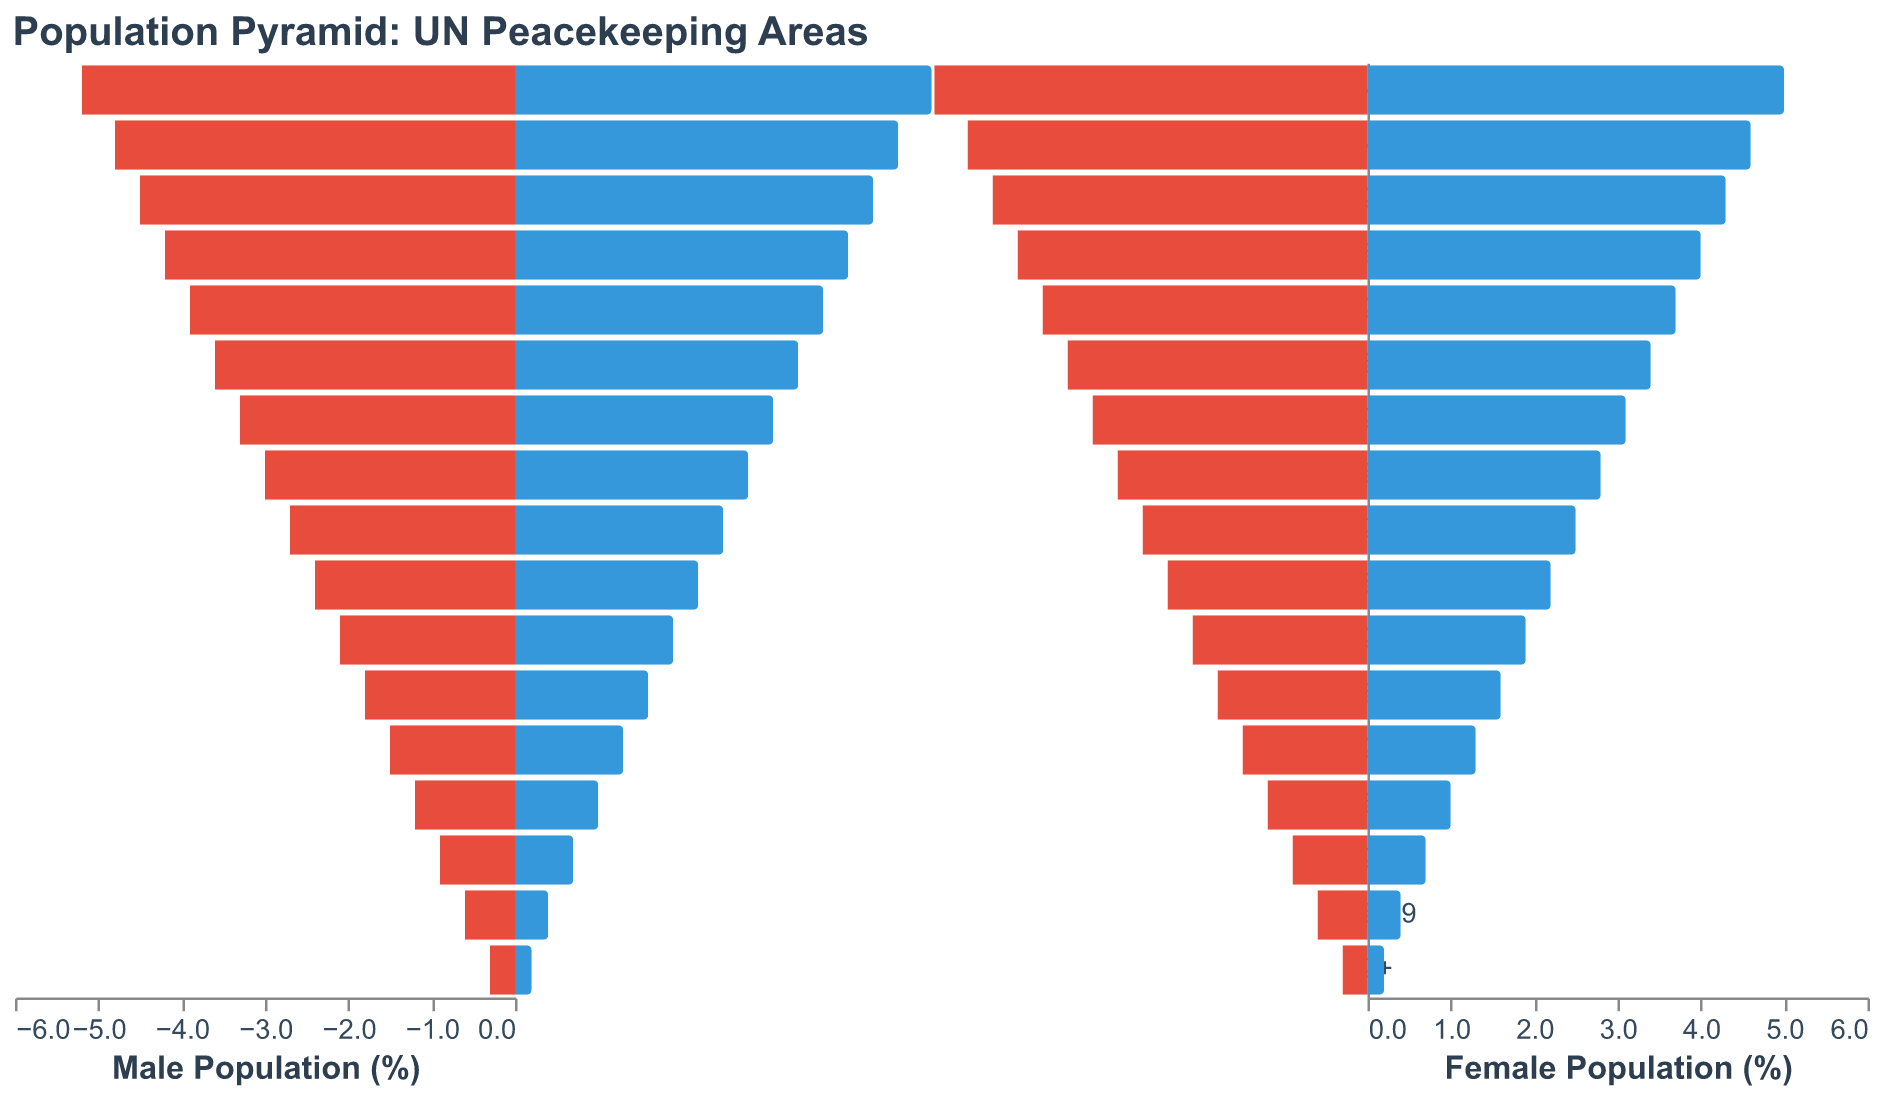What is the title of the plot? The title is clearly displayed at the top of the plot, reading "Population Pyramid: UN Peacekeeping Areas."
Answer: Population Pyramid: UN Peacekeeping Areas What is the percentage of the male population in the age group 0-4? The plot shows the male population for each age group on the left side. For the age group 0-4, the male population is indicated as 5.2%.
Answer: 5.2% Which age group has the smallest female population percentage? By examining the bars representing the female population on the right side of the plot, the age group 80+ has the smallest percentage, which is 0.2%.
Answer: 80+ What is the difference in the percentage of the male and female populations for the age group 25-29? For the age group 25-29, the percentage of the male population is 3.6%, and the female population is 3.4%. The difference is calculated as 3.6% - 3.4% = 0.2%.
Answer: 0.2% What is the combined percentage of the male and female populations for the age group 50-54? For the age group 50-54, the male population is 2.1% and the female population is 1.9%. Adding these together, 2.1% + 1.9% = 4.0%.
Answer: 4.0% How does the male population percentage change from the age group 0-4 to the age group 10-14? The male population percentage for the age group 0-4 is 5.2%, and for the age group 10-14, it is 4.5%. The change is 5.2% - 4.5% = 0.7%.
Answer: Decreases by 0.7% Which age group has a larger percentage of the population, males aged 15-19 or females aged 15-19? By looking at the plot, the male population percentage for 15-19 is 4.2%, and the female population percentage for the same age group is 4.0%. 4.2% is greater than 4.0%, indicating that males have a larger population percentage.
Answer: Males aged 15-19 What is the average percentage of the female population for the age groups 60-64 and 65-69? The female population percentage for the age group 60-64 is 1.3% and for the age group 65-69, it is 1.0%. The average is calculated as (1.3% + 1.0%) / 2 = 1.15%.
Answer: 1.15% Which gender has a higher population percentage in the age group 35-39? The figure shows that in the age group 35-39, males have a population percentage of 3.0%, whereas females have 2.8%. Thus, males have a higher population percentage in this age group.
Answer: Males How does the population percentage of females change from the age group 70-74 to 75-79? From the plot, the female population percentage for the age group 70-74 is 0.7%, and for the age group 75-79, it is 0.4%. The change is 0.7% - 0.4% = 0.3%.
Answer: Decreases by 0.3% 